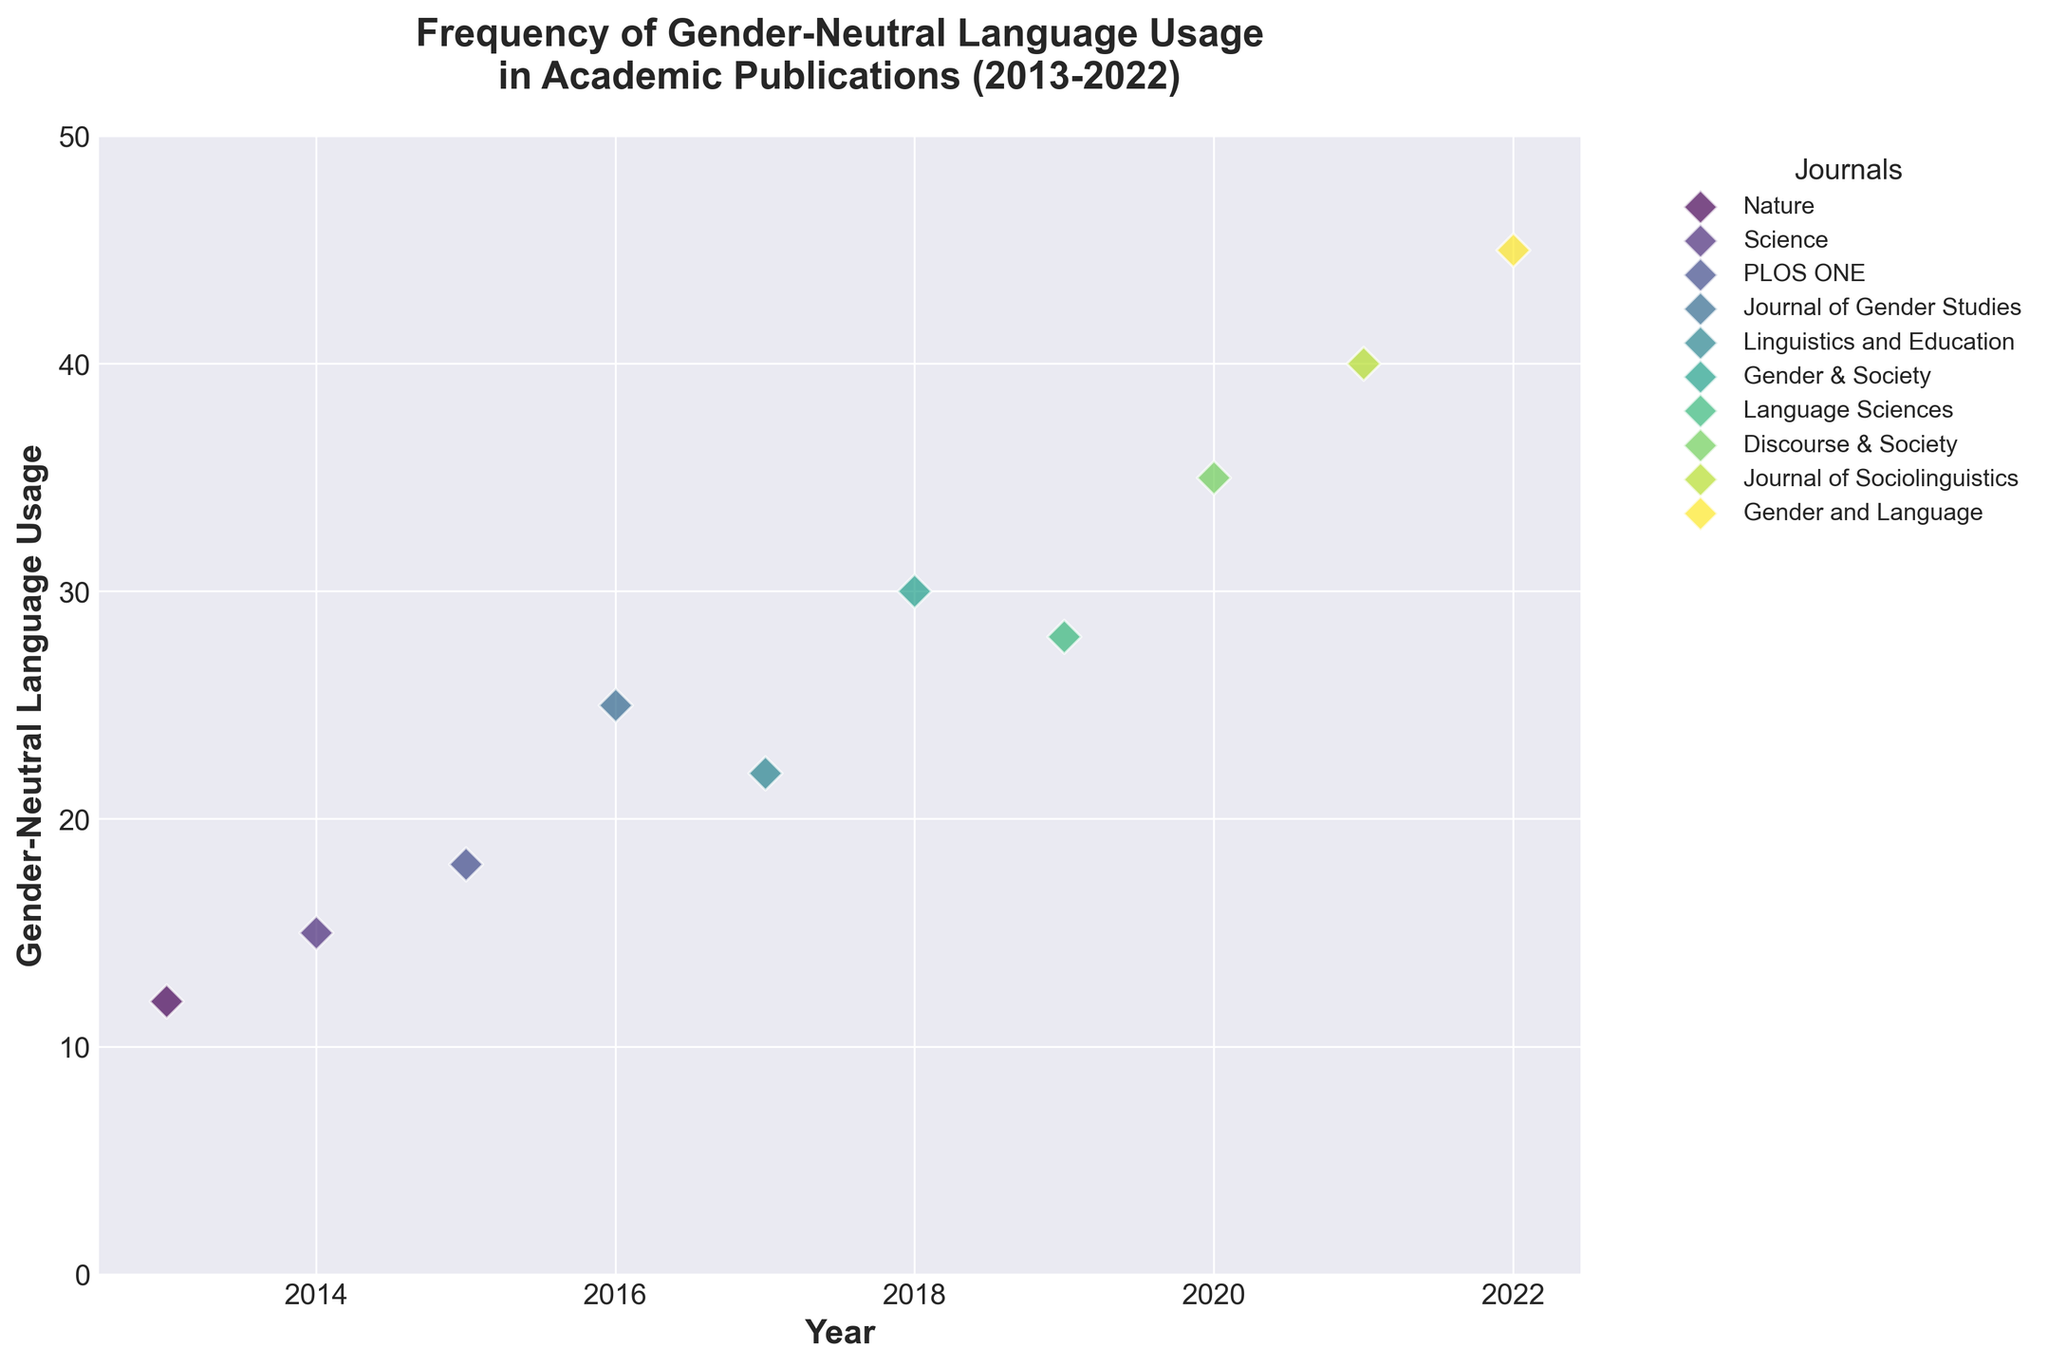What is the title of the figure? The title of the figure is written at the top of the figure and it reads "Frequency of Gender-Neutral Language Usage in Academic Publications (2013-2022)".
Answer: Frequency of Gender-Neutral Language Usage in Academic Publications (2013-2022) Which journal had the highest frequency of gender-neutral language usage in 2016? To find this, locate the year 2016 on the x-axis and identify which journal had the highest value on the y-axis for that year. The journal is "Journal of Gender Studies" with 25 instances.
Answer: Journal of Gender Studies Across all years, which journal has the highest single usage of gender-neutral language? Look for the highest point on the y-axis, which reaches 45 in the year 2022. The journal corresponding to this point is "Gender and Language".
Answer: Gender and Language How does the usage of gender-neutral language in "Science" in 2014 compare to "Discourse & Society" in 2020? Locate the points for "Science" in 2014 and "Discourse & Society" in 2020 on the plot. "Science" in 2014 has a frequency of 15, whereas "Discourse & Society" in 2020 has a frequency of 35. 35 is greater than 15, so "Discourse & Society" in 2020 used more gender-neutral language.
Answer: Discourse & Society in 2020 used more What is the average frequency of gender-neutral language usage in the dataset? Summing up all the frequencies: 12 + 15 + 18 + 25 + 22 + 30 + 28 + 35 + 40 + 45 = 270. There are 10 data points, so the average is 270 / 10 = 27.
Answer: 27 Compare the frequency of gender-neutral language in 2013 and 2021. Which year had more usage and by how much? For 2013, "Nature" had a frequency of 12. For 2021, "Journal of Sociolinguistics" had a frequency of 40. Subtracting these values: 40 - 12 = 28. 2021 had more usage by 28.
Answer: 2021 had more usage by 28 Which journal showed a frequency of 30 usages of gender-neutral terminology, and in which year? Locate the point corresponding to the frequency 30 on the y-axis. The journal is "Gender & Society" and the year is 2018.
Answer: Gender & Society in 2018 What is the difference in usage frequencies between "PLOS ONE" in 2015 and "Language Sciences" in 2019? Locate the data points for "PLOS ONE" in 2015 and "Language Sciences" in 2019. They have frequencies of 18 and 28 respectively. The difference is 28 - 18 = 10.
Answer: 10 Which two journals have the closest frequency in a given year, and what are those frequencies? Look for the pairs of data points within the same year that are closest on the y-axis. "Linguistics and Education" in 2017 and "Language Sciences" in 2019 both have frequencies of 22 and 28 respectively. The closest is "Linguistics and Education" in 2017 and "Language Sciences" in 2019.
Answer: Linguistics and Education in 2017 and Language Sciences in 2019 Over the years 2013 to 2022, what trend is observed in the usage of gender-neutral language? By observing the general trend of the points from left to right on the plot, there is a clear upward trend indicating an increase in the usage of gender-neutral language over time.
Answer: Increasing trend 